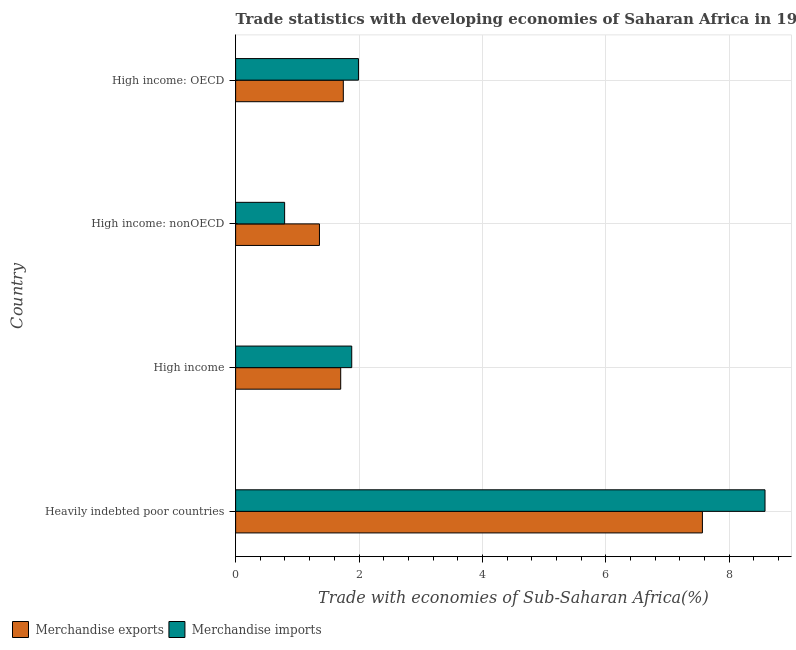How many groups of bars are there?
Give a very brief answer. 4. Are the number of bars on each tick of the Y-axis equal?
Your response must be concise. Yes. What is the label of the 1st group of bars from the top?
Your answer should be compact. High income: OECD. What is the merchandise exports in Heavily indebted poor countries?
Provide a succinct answer. 7.56. Across all countries, what is the maximum merchandise imports?
Your answer should be very brief. 8.58. Across all countries, what is the minimum merchandise exports?
Make the answer very short. 1.36. In which country was the merchandise imports maximum?
Your response must be concise. Heavily indebted poor countries. In which country was the merchandise exports minimum?
Give a very brief answer. High income: nonOECD. What is the total merchandise imports in the graph?
Your response must be concise. 13.25. What is the difference between the merchandise imports in High income: OECD and that in High income: nonOECD?
Keep it short and to the point. 1.2. What is the difference between the merchandise exports in High income: OECD and the merchandise imports in High income: nonOECD?
Your response must be concise. 0.95. What is the average merchandise exports per country?
Offer a terse response. 3.09. What is the difference between the merchandise imports and merchandise exports in High income: nonOECD?
Provide a succinct answer. -0.56. What is the ratio of the merchandise imports in Heavily indebted poor countries to that in High income: nonOECD?
Give a very brief answer. 10.8. Is the merchandise imports in Heavily indebted poor countries less than that in High income?
Offer a terse response. No. What is the difference between the highest and the second highest merchandise imports?
Offer a very short reply. 6.59. What is the difference between the highest and the lowest merchandise exports?
Ensure brevity in your answer.  6.21. In how many countries, is the merchandise exports greater than the average merchandise exports taken over all countries?
Your answer should be compact. 1. What does the 2nd bar from the top in High income: OECD represents?
Ensure brevity in your answer.  Merchandise exports. What does the 1st bar from the bottom in Heavily indebted poor countries represents?
Keep it short and to the point. Merchandise exports. Are all the bars in the graph horizontal?
Your answer should be compact. Yes. How many countries are there in the graph?
Provide a short and direct response. 4. Are the values on the major ticks of X-axis written in scientific E-notation?
Your answer should be compact. No. Does the graph contain any zero values?
Your answer should be compact. No. Does the graph contain grids?
Your response must be concise. Yes. How many legend labels are there?
Your answer should be compact. 2. What is the title of the graph?
Give a very brief answer. Trade statistics with developing economies of Saharan Africa in 1987. What is the label or title of the X-axis?
Your answer should be very brief. Trade with economies of Sub-Saharan Africa(%). What is the Trade with economies of Sub-Saharan Africa(%) of Merchandise exports in Heavily indebted poor countries?
Provide a short and direct response. 7.56. What is the Trade with economies of Sub-Saharan Africa(%) of Merchandise imports in Heavily indebted poor countries?
Provide a short and direct response. 8.58. What is the Trade with economies of Sub-Saharan Africa(%) in Merchandise exports in High income?
Ensure brevity in your answer.  1.7. What is the Trade with economies of Sub-Saharan Africa(%) of Merchandise imports in High income?
Keep it short and to the point. 1.88. What is the Trade with economies of Sub-Saharan Africa(%) in Merchandise exports in High income: nonOECD?
Offer a very short reply. 1.36. What is the Trade with economies of Sub-Saharan Africa(%) in Merchandise imports in High income: nonOECD?
Provide a succinct answer. 0.79. What is the Trade with economies of Sub-Saharan Africa(%) of Merchandise exports in High income: OECD?
Ensure brevity in your answer.  1.75. What is the Trade with economies of Sub-Saharan Africa(%) of Merchandise imports in High income: OECD?
Offer a very short reply. 1.99. Across all countries, what is the maximum Trade with economies of Sub-Saharan Africa(%) in Merchandise exports?
Keep it short and to the point. 7.56. Across all countries, what is the maximum Trade with economies of Sub-Saharan Africa(%) in Merchandise imports?
Keep it short and to the point. 8.58. Across all countries, what is the minimum Trade with economies of Sub-Saharan Africa(%) in Merchandise exports?
Make the answer very short. 1.36. Across all countries, what is the minimum Trade with economies of Sub-Saharan Africa(%) of Merchandise imports?
Provide a succinct answer. 0.79. What is the total Trade with economies of Sub-Saharan Africa(%) of Merchandise exports in the graph?
Offer a terse response. 12.37. What is the total Trade with economies of Sub-Saharan Africa(%) in Merchandise imports in the graph?
Make the answer very short. 13.25. What is the difference between the Trade with economies of Sub-Saharan Africa(%) in Merchandise exports in Heavily indebted poor countries and that in High income?
Keep it short and to the point. 5.86. What is the difference between the Trade with economies of Sub-Saharan Africa(%) in Merchandise imports in Heavily indebted poor countries and that in High income?
Offer a terse response. 6.7. What is the difference between the Trade with economies of Sub-Saharan Africa(%) in Merchandise exports in Heavily indebted poor countries and that in High income: nonOECD?
Offer a very short reply. 6.21. What is the difference between the Trade with economies of Sub-Saharan Africa(%) of Merchandise imports in Heavily indebted poor countries and that in High income: nonOECD?
Offer a very short reply. 7.78. What is the difference between the Trade with economies of Sub-Saharan Africa(%) in Merchandise exports in Heavily indebted poor countries and that in High income: OECD?
Provide a succinct answer. 5.82. What is the difference between the Trade with economies of Sub-Saharan Africa(%) of Merchandise imports in Heavily indebted poor countries and that in High income: OECD?
Provide a short and direct response. 6.59. What is the difference between the Trade with economies of Sub-Saharan Africa(%) in Merchandise exports in High income and that in High income: nonOECD?
Provide a short and direct response. 0.34. What is the difference between the Trade with economies of Sub-Saharan Africa(%) in Merchandise imports in High income and that in High income: nonOECD?
Provide a short and direct response. 1.09. What is the difference between the Trade with economies of Sub-Saharan Africa(%) of Merchandise exports in High income and that in High income: OECD?
Offer a terse response. -0.04. What is the difference between the Trade with economies of Sub-Saharan Africa(%) in Merchandise imports in High income and that in High income: OECD?
Offer a terse response. -0.11. What is the difference between the Trade with economies of Sub-Saharan Africa(%) in Merchandise exports in High income: nonOECD and that in High income: OECD?
Keep it short and to the point. -0.39. What is the difference between the Trade with economies of Sub-Saharan Africa(%) of Merchandise imports in High income: nonOECD and that in High income: OECD?
Give a very brief answer. -1.2. What is the difference between the Trade with economies of Sub-Saharan Africa(%) of Merchandise exports in Heavily indebted poor countries and the Trade with economies of Sub-Saharan Africa(%) of Merchandise imports in High income?
Provide a succinct answer. 5.68. What is the difference between the Trade with economies of Sub-Saharan Africa(%) in Merchandise exports in Heavily indebted poor countries and the Trade with economies of Sub-Saharan Africa(%) in Merchandise imports in High income: nonOECD?
Offer a very short reply. 6.77. What is the difference between the Trade with economies of Sub-Saharan Africa(%) of Merchandise exports in Heavily indebted poor countries and the Trade with economies of Sub-Saharan Africa(%) of Merchandise imports in High income: OECD?
Offer a terse response. 5.57. What is the difference between the Trade with economies of Sub-Saharan Africa(%) of Merchandise exports in High income and the Trade with economies of Sub-Saharan Africa(%) of Merchandise imports in High income: nonOECD?
Your answer should be compact. 0.91. What is the difference between the Trade with economies of Sub-Saharan Africa(%) of Merchandise exports in High income and the Trade with economies of Sub-Saharan Africa(%) of Merchandise imports in High income: OECD?
Provide a succinct answer. -0.29. What is the difference between the Trade with economies of Sub-Saharan Africa(%) of Merchandise exports in High income: nonOECD and the Trade with economies of Sub-Saharan Africa(%) of Merchandise imports in High income: OECD?
Ensure brevity in your answer.  -0.63. What is the average Trade with economies of Sub-Saharan Africa(%) in Merchandise exports per country?
Your answer should be very brief. 3.09. What is the average Trade with economies of Sub-Saharan Africa(%) in Merchandise imports per country?
Your answer should be very brief. 3.31. What is the difference between the Trade with economies of Sub-Saharan Africa(%) in Merchandise exports and Trade with economies of Sub-Saharan Africa(%) in Merchandise imports in Heavily indebted poor countries?
Ensure brevity in your answer.  -1.01. What is the difference between the Trade with economies of Sub-Saharan Africa(%) in Merchandise exports and Trade with economies of Sub-Saharan Africa(%) in Merchandise imports in High income?
Provide a short and direct response. -0.18. What is the difference between the Trade with economies of Sub-Saharan Africa(%) in Merchandise exports and Trade with economies of Sub-Saharan Africa(%) in Merchandise imports in High income: nonOECD?
Your response must be concise. 0.56. What is the difference between the Trade with economies of Sub-Saharan Africa(%) of Merchandise exports and Trade with economies of Sub-Saharan Africa(%) of Merchandise imports in High income: OECD?
Provide a succinct answer. -0.25. What is the ratio of the Trade with economies of Sub-Saharan Africa(%) of Merchandise exports in Heavily indebted poor countries to that in High income?
Give a very brief answer. 4.44. What is the ratio of the Trade with economies of Sub-Saharan Africa(%) in Merchandise imports in Heavily indebted poor countries to that in High income?
Your response must be concise. 4.56. What is the ratio of the Trade with economies of Sub-Saharan Africa(%) in Merchandise exports in Heavily indebted poor countries to that in High income: nonOECD?
Ensure brevity in your answer.  5.57. What is the ratio of the Trade with economies of Sub-Saharan Africa(%) of Merchandise imports in Heavily indebted poor countries to that in High income: nonOECD?
Give a very brief answer. 10.8. What is the ratio of the Trade with economies of Sub-Saharan Africa(%) in Merchandise exports in Heavily indebted poor countries to that in High income: OECD?
Offer a very short reply. 4.33. What is the ratio of the Trade with economies of Sub-Saharan Africa(%) in Merchandise imports in Heavily indebted poor countries to that in High income: OECD?
Provide a short and direct response. 4.31. What is the ratio of the Trade with economies of Sub-Saharan Africa(%) of Merchandise exports in High income to that in High income: nonOECD?
Offer a terse response. 1.25. What is the ratio of the Trade with economies of Sub-Saharan Africa(%) in Merchandise imports in High income to that in High income: nonOECD?
Your answer should be very brief. 2.37. What is the ratio of the Trade with economies of Sub-Saharan Africa(%) of Merchandise exports in High income to that in High income: OECD?
Your response must be concise. 0.98. What is the ratio of the Trade with economies of Sub-Saharan Africa(%) of Merchandise imports in High income to that in High income: OECD?
Keep it short and to the point. 0.95. What is the ratio of the Trade with economies of Sub-Saharan Africa(%) in Merchandise exports in High income: nonOECD to that in High income: OECD?
Your answer should be compact. 0.78. What is the ratio of the Trade with economies of Sub-Saharan Africa(%) in Merchandise imports in High income: nonOECD to that in High income: OECD?
Your answer should be compact. 0.4. What is the difference between the highest and the second highest Trade with economies of Sub-Saharan Africa(%) in Merchandise exports?
Offer a terse response. 5.82. What is the difference between the highest and the second highest Trade with economies of Sub-Saharan Africa(%) of Merchandise imports?
Give a very brief answer. 6.59. What is the difference between the highest and the lowest Trade with economies of Sub-Saharan Africa(%) in Merchandise exports?
Give a very brief answer. 6.21. What is the difference between the highest and the lowest Trade with economies of Sub-Saharan Africa(%) of Merchandise imports?
Make the answer very short. 7.78. 